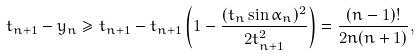Convert formula to latex. <formula><loc_0><loc_0><loc_500><loc_500>t _ { n + 1 } - y _ { n } \geq t _ { n + 1 } - t _ { n + 1 } \left ( 1 - \frac { ( t _ { n } \sin \alpha _ { n } ) ^ { 2 } } { 2 t _ { n + 1 } ^ { 2 } } \right ) = \frac { ( n - 1 ) ! } { 2 n ( n + 1 ) } ,</formula> 